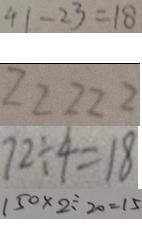<formula> <loc_0><loc_0><loc_500><loc_500>4 1 - 2 3 = 1 8 
 2 2 2 2 2 
 7 2 \div 4 = 1 8 
 1 5 0 \times 2 \div 2 0 = 1 5</formula> 